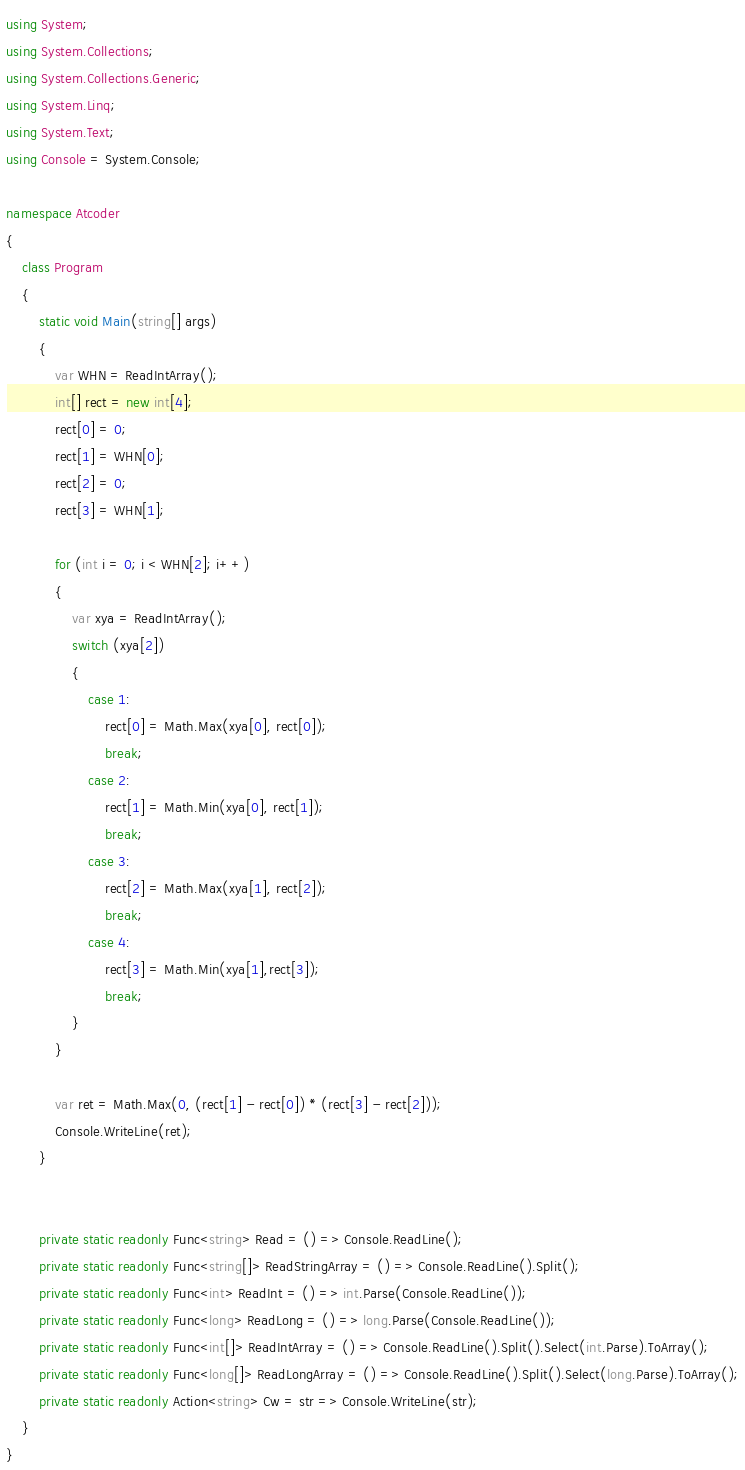<code> <loc_0><loc_0><loc_500><loc_500><_C#_>using System;
using System.Collections;
using System.Collections.Generic;
using System.Linq;
using System.Text;
using Console = System.Console;

namespace Atcoder
{
    class Program
    {
        static void Main(string[] args)
        {
            var WHN = ReadIntArray();
            int[] rect = new int[4];
            rect[0] = 0;
            rect[1] = WHN[0];
            rect[2] = 0;
            rect[3] = WHN[1];

            for (int i = 0; i < WHN[2]; i++)
            {
                var xya = ReadIntArray();
                switch (xya[2])
                {
                    case 1:
                        rect[0] = Math.Max(xya[0], rect[0]);
                        break;
                    case 2:
                        rect[1] = Math.Min(xya[0], rect[1]);
                        break;
                    case 3:
                        rect[2] = Math.Max(xya[1], rect[2]);
                        break;
                    case 4:
                        rect[3] = Math.Min(xya[1],rect[3]);
                        break;
                }
            }

            var ret = Math.Max(0, (rect[1] - rect[0]) * (rect[3] - rect[2]));
            Console.WriteLine(ret);
        }


        private static readonly Func<string> Read = () => Console.ReadLine();
        private static readonly Func<string[]> ReadStringArray = () => Console.ReadLine().Split();
        private static readonly Func<int> ReadInt = () => int.Parse(Console.ReadLine());
        private static readonly Func<long> ReadLong = () => long.Parse(Console.ReadLine());
        private static readonly Func<int[]> ReadIntArray = () => Console.ReadLine().Split().Select(int.Parse).ToArray();
        private static readonly Func<long[]> ReadLongArray = () => Console.ReadLine().Split().Select(long.Parse).ToArray();
        private static readonly Action<string> Cw = str => Console.WriteLine(str);
    }
}</code> 